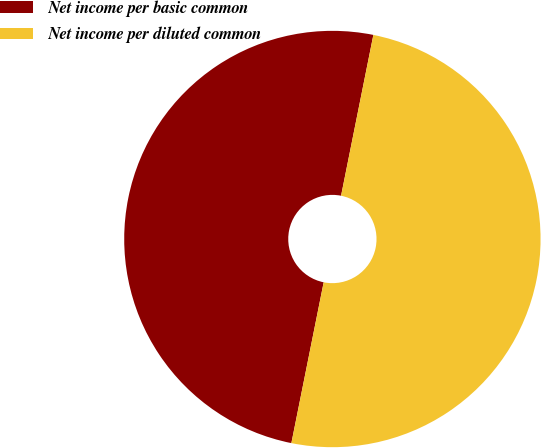<chart> <loc_0><loc_0><loc_500><loc_500><pie_chart><fcel>Net income per basic common<fcel>Net income per diluted common<nl><fcel>50.0%<fcel>50.0%<nl></chart> 